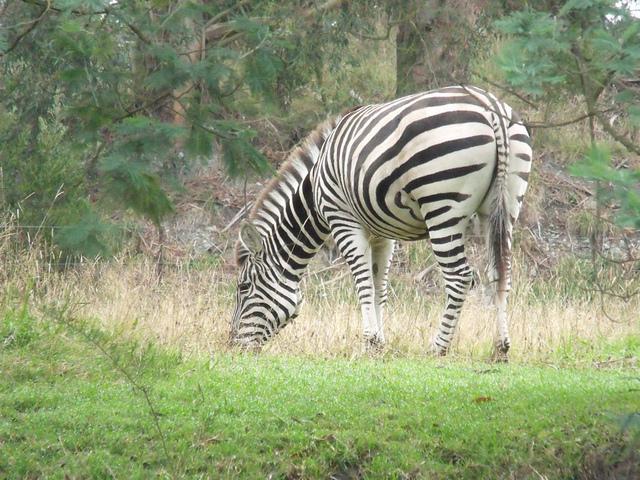Is the zebra fat?
Answer briefly. Yes. What is the zebra doing in the forest?
Quick response, please. Eating. Is this zebra alone?
Write a very short answer. Yes. 